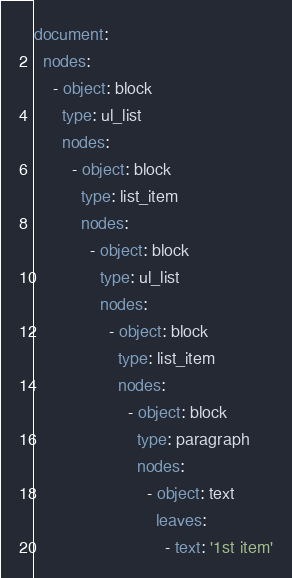Convert code to text. <code><loc_0><loc_0><loc_500><loc_500><_YAML_>document:
  nodes:
    - object: block
      type: ul_list
      nodes:
        - object: block
          type: list_item
          nodes:
            - object: block
              type: ul_list
              nodes:
                - object: block
                  type: list_item
                  nodes:
                    - object: block
                      type: paragraph
                      nodes:
                        - object: text
                          leaves:
                            - text: '1st item'
</code> 